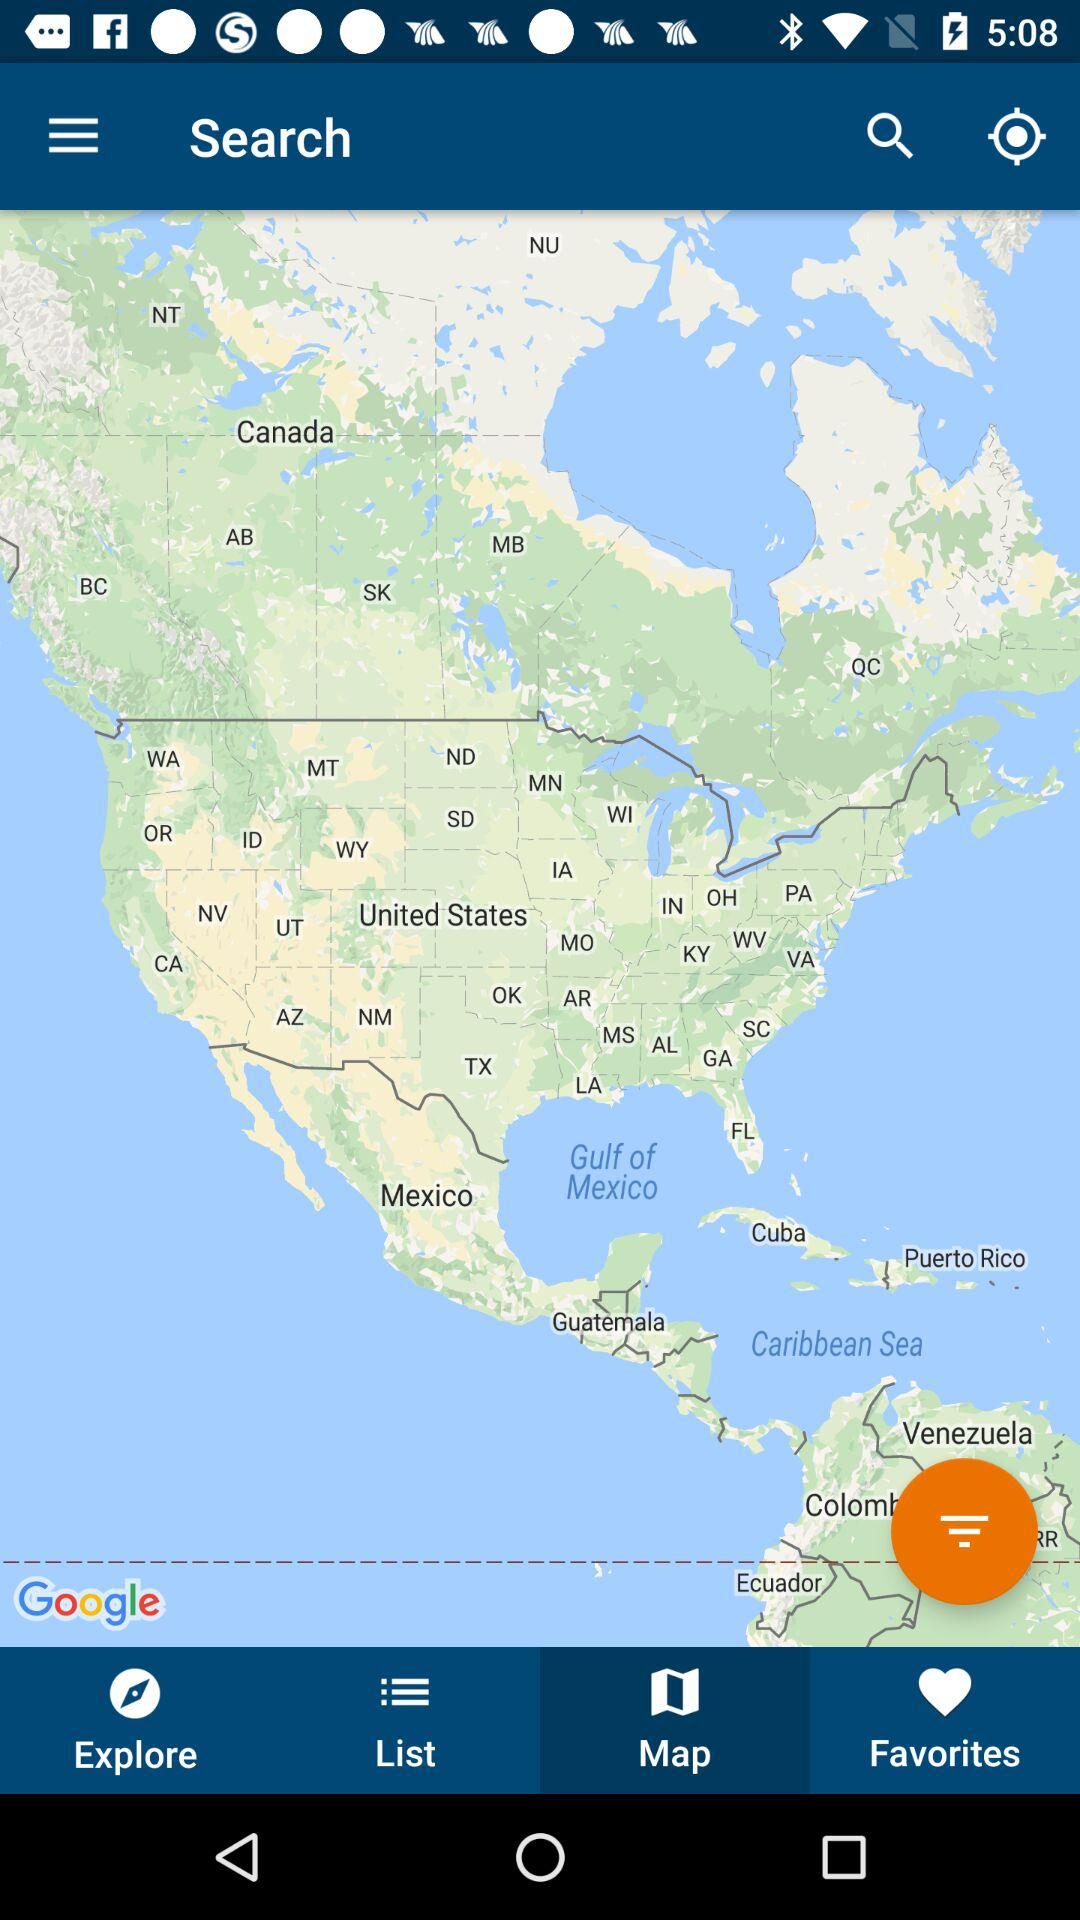Which tab is currently selected at the bottom bar? The selected tab is "Map". 